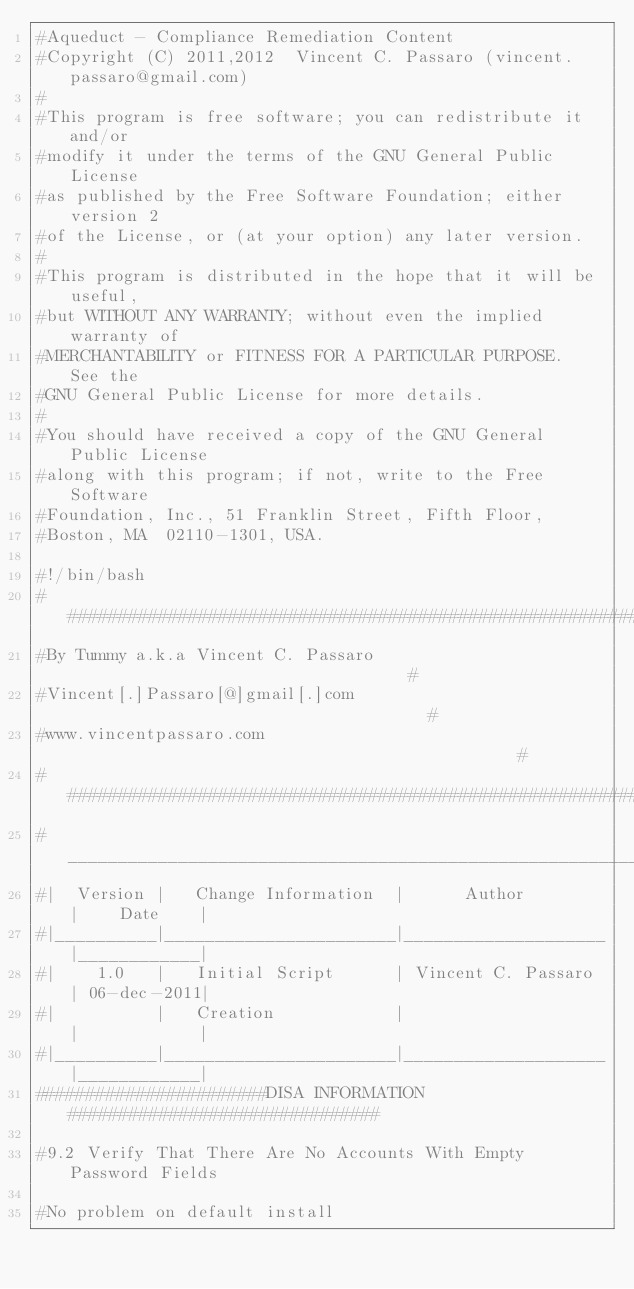Convert code to text. <code><loc_0><loc_0><loc_500><loc_500><_Bash_>#Aqueduct - Compliance Remediation Content
#Copyright (C) 2011,2012  Vincent C. Passaro (vincent.passaro@gmail.com)
#
#This program is free software; you can redistribute it and/or
#modify it under the terms of the GNU General Public License
#as published by the Free Software Foundation; either version 2
#of the License, or (at your option) any later version.
#
#This program is distributed in the hope that it will be useful,
#but WITHOUT ANY WARRANTY; without even the implied warranty of
#MERCHANTABILITY or FITNESS FOR A PARTICULAR PURPOSE.  See the
#GNU General Public License for more details.
#
#You should have received a copy of the GNU General Public License
#along with this program; if not, write to the Free Software
#Foundation, Inc., 51 Franklin Street, Fifth Floor,
#Boston, MA  02110-1301, USA.

#!/bin/bash
######################################################################
#By Tummy a.k.a Vincent C. Passaro                                   #
#Vincent[.]Passaro[@]gmail[.]com                                     #
#www.vincentpassaro.com                                              #
######################################################################
#_____________________________________________________________________
#|  Version |   Change Information  |      Author        |    Date    |
#|__________|_______________________|____________________|____________|
#|    1.0   |   Initial Script      | Vincent C. Passaro | 06-dec-2011|
#|          |   Creation            |                    |            |
#|__________|_______________________|____________________|____________|
#######################DISA INFORMATION###############################

#9.2 Verify That There Are No Accounts With Empty Password Fields

#No problem on default install</code> 